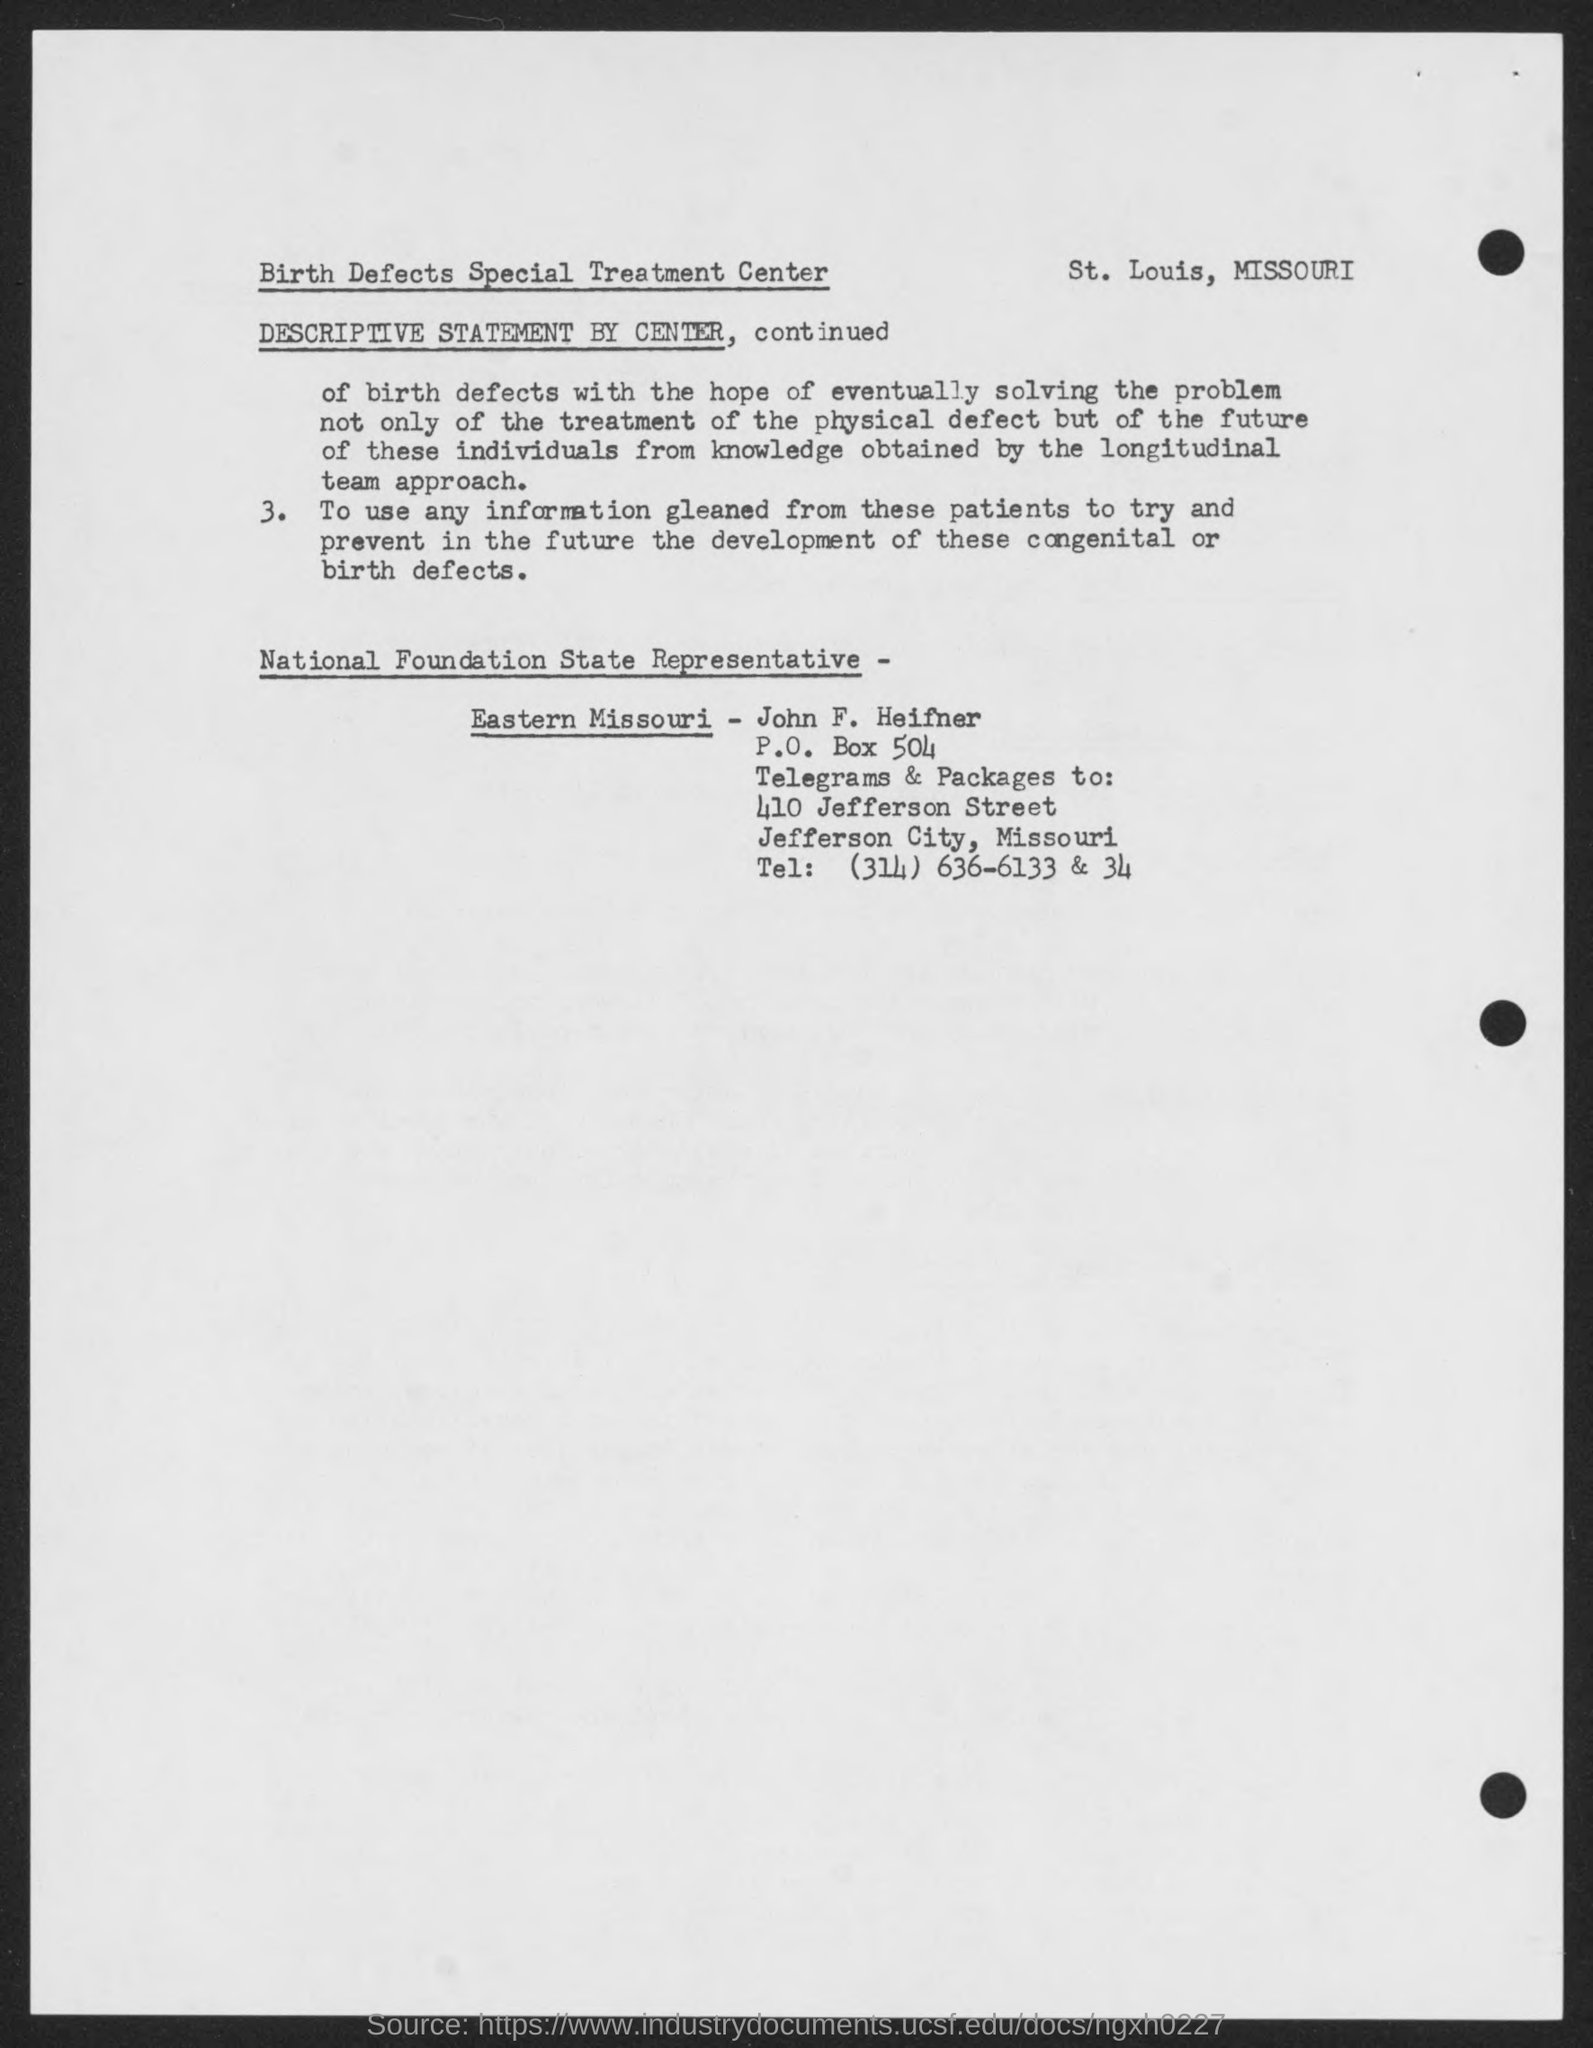Specify some key components in this picture. The telephone number mentioned in the document is (314) 636-6133 and 34.. The P.O. Box number provided in the address is 504. John F. Heifner is the National Foundation State Representative-Eastern Missouri. 